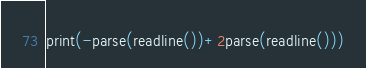<code> <loc_0><loc_0><loc_500><loc_500><_Julia_>print(-parse(readline())+2parse(readline()))</code> 